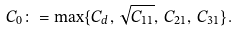Convert formula to latex. <formula><loc_0><loc_0><loc_500><loc_500>C _ { 0 } \colon = \max \{ C _ { d } , \, \sqrt { C _ { 1 1 } } , \, C _ { 2 1 } , \, C _ { 3 1 } \} .</formula> 